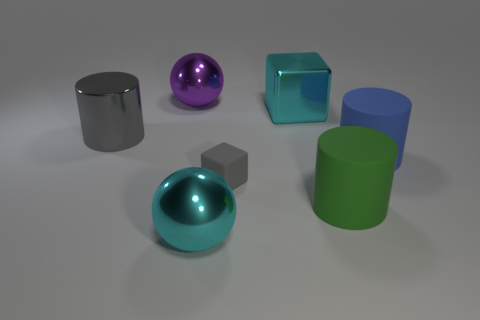Add 1 tiny brown cylinders. How many objects exist? 8 Subtract all cylinders. How many objects are left? 4 Add 5 cyan metal things. How many cyan metal things are left? 7 Add 4 tiny objects. How many tiny objects exist? 5 Subtract 0 green cubes. How many objects are left? 7 Subtract all big purple metallic balls. Subtract all large cylinders. How many objects are left? 3 